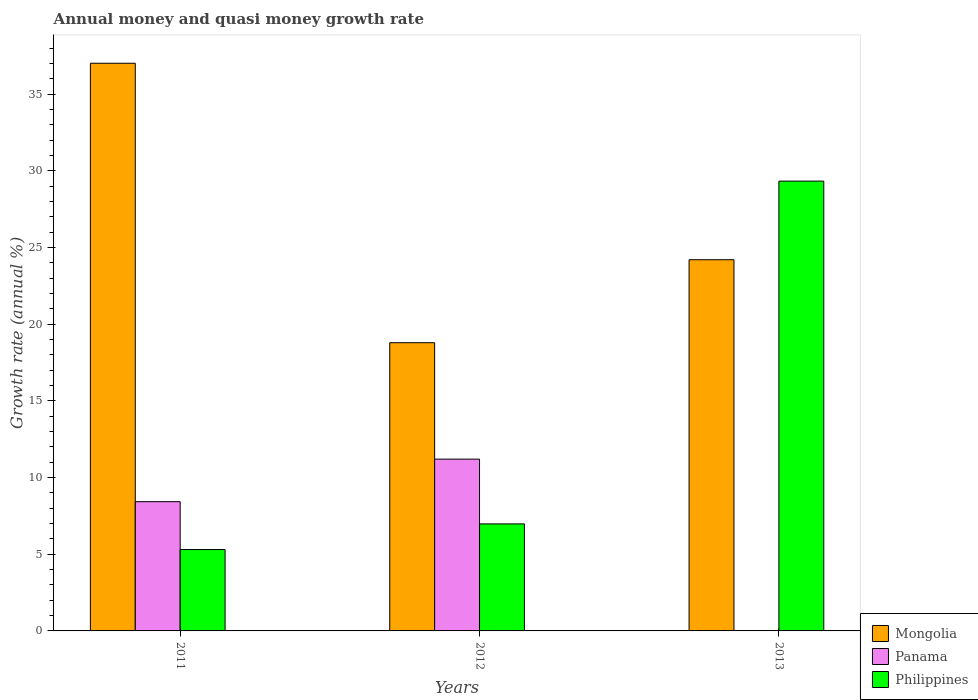How many different coloured bars are there?
Your answer should be compact. 3. Are the number of bars per tick equal to the number of legend labels?
Provide a short and direct response. No. How many bars are there on the 1st tick from the left?
Ensure brevity in your answer.  3. How many bars are there on the 2nd tick from the right?
Give a very brief answer. 3. In how many cases, is the number of bars for a given year not equal to the number of legend labels?
Offer a terse response. 1. What is the growth rate in Mongolia in 2011?
Offer a very short reply. 37.01. Across all years, what is the maximum growth rate in Philippines?
Provide a succinct answer. 29.33. Across all years, what is the minimum growth rate in Philippines?
Your response must be concise. 5.31. In which year was the growth rate in Mongolia maximum?
Provide a succinct answer. 2011. What is the total growth rate in Mongolia in the graph?
Give a very brief answer. 80.01. What is the difference between the growth rate in Philippines in 2011 and that in 2012?
Ensure brevity in your answer.  -1.67. What is the difference between the growth rate in Philippines in 2011 and the growth rate in Mongolia in 2013?
Offer a very short reply. -18.9. What is the average growth rate in Panama per year?
Ensure brevity in your answer.  6.54. In the year 2012, what is the difference between the growth rate in Panama and growth rate in Mongolia?
Offer a terse response. -7.59. What is the ratio of the growth rate in Mongolia in 2012 to that in 2013?
Your response must be concise. 0.78. What is the difference between the highest and the second highest growth rate in Philippines?
Provide a short and direct response. 22.35. What is the difference between the highest and the lowest growth rate in Philippines?
Ensure brevity in your answer.  24.02. Are all the bars in the graph horizontal?
Your answer should be very brief. No. What is the difference between two consecutive major ticks on the Y-axis?
Provide a short and direct response. 5. Are the values on the major ticks of Y-axis written in scientific E-notation?
Your answer should be very brief. No. Does the graph contain any zero values?
Provide a short and direct response. Yes. Does the graph contain grids?
Keep it short and to the point. No. How are the legend labels stacked?
Make the answer very short. Vertical. What is the title of the graph?
Give a very brief answer. Annual money and quasi money growth rate. What is the label or title of the Y-axis?
Provide a succinct answer. Growth rate (annual %). What is the Growth rate (annual %) of Mongolia in 2011?
Ensure brevity in your answer.  37.01. What is the Growth rate (annual %) of Panama in 2011?
Provide a succinct answer. 8.43. What is the Growth rate (annual %) of Philippines in 2011?
Keep it short and to the point. 5.31. What is the Growth rate (annual %) in Mongolia in 2012?
Your answer should be very brief. 18.79. What is the Growth rate (annual %) in Panama in 2012?
Keep it short and to the point. 11.2. What is the Growth rate (annual %) of Philippines in 2012?
Offer a terse response. 6.98. What is the Growth rate (annual %) in Mongolia in 2013?
Give a very brief answer. 24.2. What is the Growth rate (annual %) in Panama in 2013?
Your answer should be very brief. 0. What is the Growth rate (annual %) of Philippines in 2013?
Your response must be concise. 29.33. Across all years, what is the maximum Growth rate (annual %) in Mongolia?
Give a very brief answer. 37.01. Across all years, what is the maximum Growth rate (annual %) of Panama?
Give a very brief answer. 11.2. Across all years, what is the maximum Growth rate (annual %) of Philippines?
Provide a short and direct response. 29.33. Across all years, what is the minimum Growth rate (annual %) in Mongolia?
Offer a terse response. 18.79. Across all years, what is the minimum Growth rate (annual %) in Philippines?
Your answer should be very brief. 5.31. What is the total Growth rate (annual %) in Mongolia in the graph?
Your response must be concise. 80.01. What is the total Growth rate (annual %) of Panama in the graph?
Keep it short and to the point. 19.63. What is the total Growth rate (annual %) of Philippines in the graph?
Your response must be concise. 41.61. What is the difference between the Growth rate (annual %) in Mongolia in 2011 and that in 2012?
Your answer should be very brief. 18.22. What is the difference between the Growth rate (annual %) in Panama in 2011 and that in 2012?
Provide a succinct answer. -2.77. What is the difference between the Growth rate (annual %) of Philippines in 2011 and that in 2012?
Your answer should be very brief. -1.67. What is the difference between the Growth rate (annual %) in Mongolia in 2011 and that in 2013?
Your answer should be very brief. 12.81. What is the difference between the Growth rate (annual %) of Philippines in 2011 and that in 2013?
Your answer should be compact. -24.02. What is the difference between the Growth rate (annual %) in Mongolia in 2012 and that in 2013?
Your answer should be very brief. -5.41. What is the difference between the Growth rate (annual %) in Philippines in 2012 and that in 2013?
Give a very brief answer. -22.35. What is the difference between the Growth rate (annual %) of Mongolia in 2011 and the Growth rate (annual %) of Panama in 2012?
Provide a short and direct response. 25.81. What is the difference between the Growth rate (annual %) of Mongolia in 2011 and the Growth rate (annual %) of Philippines in 2012?
Give a very brief answer. 30.04. What is the difference between the Growth rate (annual %) of Panama in 2011 and the Growth rate (annual %) of Philippines in 2012?
Provide a succinct answer. 1.45. What is the difference between the Growth rate (annual %) of Mongolia in 2011 and the Growth rate (annual %) of Philippines in 2013?
Your response must be concise. 7.69. What is the difference between the Growth rate (annual %) in Panama in 2011 and the Growth rate (annual %) in Philippines in 2013?
Offer a terse response. -20.9. What is the difference between the Growth rate (annual %) in Mongolia in 2012 and the Growth rate (annual %) in Philippines in 2013?
Offer a very short reply. -10.54. What is the difference between the Growth rate (annual %) of Panama in 2012 and the Growth rate (annual %) of Philippines in 2013?
Keep it short and to the point. -18.13. What is the average Growth rate (annual %) of Mongolia per year?
Offer a very short reply. 26.67. What is the average Growth rate (annual %) in Panama per year?
Offer a very short reply. 6.54. What is the average Growth rate (annual %) in Philippines per year?
Your answer should be very brief. 13.87. In the year 2011, what is the difference between the Growth rate (annual %) of Mongolia and Growth rate (annual %) of Panama?
Your answer should be compact. 28.59. In the year 2011, what is the difference between the Growth rate (annual %) of Mongolia and Growth rate (annual %) of Philippines?
Your response must be concise. 31.71. In the year 2011, what is the difference between the Growth rate (annual %) in Panama and Growth rate (annual %) in Philippines?
Make the answer very short. 3.12. In the year 2012, what is the difference between the Growth rate (annual %) of Mongolia and Growth rate (annual %) of Panama?
Provide a short and direct response. 7.59. In the year 2012, what is the difference between the Growth rate (annual %) of Mongolia and Growth rate (annual %) of Philippines?
Give a very brief answer. 11.81. In the year 2012, what is the difference between the Growth rate (annual %) of Panama and Growth rate (annual %) of Philippines?
Your response must be concise. 4.22. In the year 2013, what is the difference between the Growth rate (annual %) of Mongolia and Growth rate (annual %) of Philippines?
Provide a short and direct response. -5.13. What is the ratio of the Growth rate (annual %) in Mongolia in 2011 to that in 2012?
Your answer should be compact. 1.97. What is the ratio of the Growth rate (annual %) of Panama in 2011 to that in 2012?
Give a very brief answer. 0.75. What is the ratio of the Growth rate (annual %) in Philippines in 2011 to that in 2012?
Offer a terse response. 0.76. What is the ratio of the Growth rate (annual %) of Mongolia in 2011 to that in 2013?
Offer a very short reply. 1.53. What is the ratio of the Growth rate (annual %) of Philippines in 2011 to that in 2013?
Your answer should be compact. 0.18. What is the ratio of the Growth rate (annual %) in Mongolia in 2012 to that in 2013?
Offer a very short reply. 0.78. What is the ratio of the Growth rate (annual %) in Philippines in 2012 to that in 2013?
Offer a terse response. 0.24. What is the difference between the highest and the second highest Growth rate (annual %) in Mongolia?
Keep it short and to the point. 12.81. What is the difference between the highest and the second highest Growth rate (annual %) in Philippines?
Your answer should be compact. 22.35. What is the difference between the highest and the lowest Growth rate (annual %) of Mongolia?
Provide a succinct answer. 18.22. What is the difference between the highest and the lowest Growth rate (annual %) of Panama?
Offer a terse response. 11.2. What is the difference between the highest and the lowest Growth rate (annual %) of Philippines?
Keep it short and to the point. 24.02. 